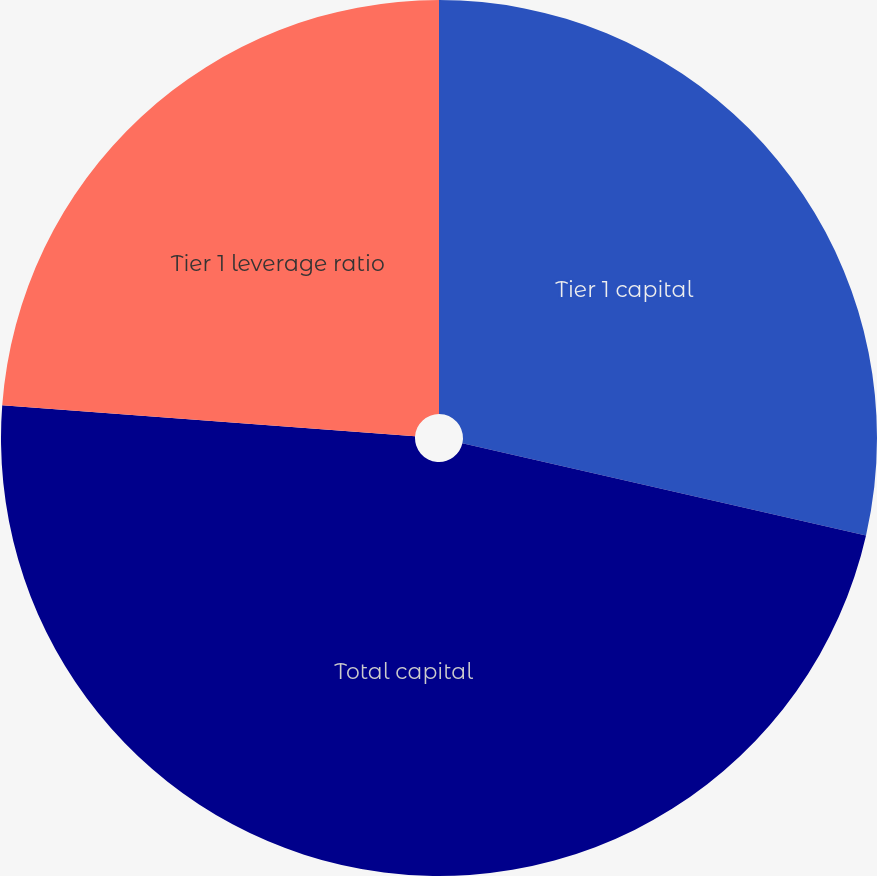<chart> <loc_0><loc_0><loc_500><loc_500><pie_chart><fcel>Tier 1 capital<fcel>Total capital<fcel>Tier 1 leverage ratio<nl><fcel>28.57%<fcel>47.62%<fcel>23.81%<nl></chart> 